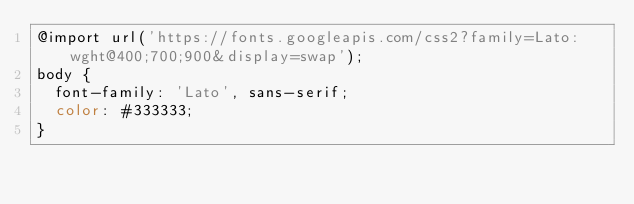Convert code to text. <code><loc_0><loc_0><loc_500><loc_500><_CSS_>@import url('https://fonts.googleapis.com/css2?family=Lato:wght@400;700;900&display=swap');
body {
  font-family: 'Lato', sans-serif;
  color: #333333;
}</code> 